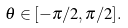<formula> <loc_0><loc_0><loc_500><loc_500>\theta \in [ - \pi / 2 , \pi / 2 ] .</formula> 